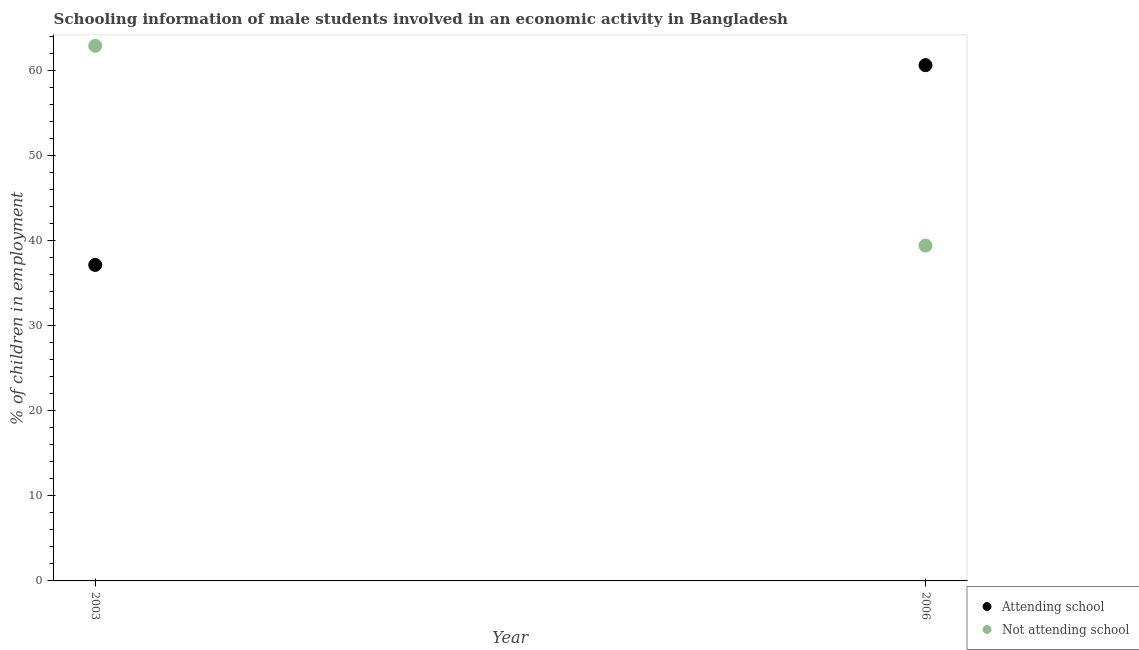What is the percentage of employed males who are not attending school in 2003?
Provide a succinct answer. 62.87. Across all years, what is the maximum percentage of employed males who are attending school?
Make the answer very short. 60.6. Across all years, what is the minimum percentage of employed males who are attending school?
Provide a succinct answer. 37.13. In which year was the percentage of employed males who are attending school maximum?
Your answer should be very brief. 2006. What is the total percentage of employed males who are attending school in the graph?
Offer a terse response. 97.73. What is the difference between the percentage of employed males who are not attending school in 2003 and that in 2006?
Your response must be concise. 23.47. What is the difference between the percentage of employed males who are attending school in 2003 and the percentage of employed males who are not attending school in 2006?
Your response must be concise. -2.27. What is the average percentage of employed males who are not attending school per year?
Your answer should be compact. 51.14. In the year 2006, what is the difference between the percentage of employed males who are attending school and percentage of employed males who are not attending school?
Provide a short and direct response. 21.2. What is the ratio of the percentage of employed males who are attending school in 2003 to that in 2006?
Make the answer very short. 0.61. Is the percentage of employed males who are attending school in 2003 less than that in 2006?
Your answer should be compact. Yes. In how many years, is the percentage of employed males who are attending school greater than the average percentage of employed males who are attending school taken over all years?
Your answer should be very brief. 1. Is the percentage of employed males who are attending school strictly less than the percentage of employed males who are not attending school over the years?
Offer a terse response. No. How many years are there in the graph?
Ensure brevity in your answer.  2. What is the difference between two consecutive major ticks on the Y-axis?
Your answer should be very brief. 10. How are the legend labels stacked?
Ensure brevity in your answer.  Vertical. What is the title of the graph?
Provide a succinct answer. Schooling information of male students involved in an economic activity in Bangladesh. Does "current US$" appear as one of the legend labels in the graph?
Make the answer very short. No. What is the label or title of the Y-axis?
Your answer should be compact. % of children in employment. What is the % of children in employment of Attending school in 2003?
Provide a short and direct response. 37.13. What is the % of children in employment in Not attending school in 2003?
Offer a terse response. 62.87. What is the % of children in employment in Attending school in 2006?
Give a very brief answer. 60.6. What is the % of children in employment in Not attending school in 2006?
Provide a succinct answer. 39.4. Across all years, what is the maximum % of children in employment of Attending school?
Offer a terse response. 60.6. Across all years, what is the maximum % of children in employment in Not attending school?
Your answer should be compact. 62.87. Across all years, what is the minimum % of children in employment in Attending school?
Provide a short and direct response. 37.13. Across all years, what is the minimum % of children in employment of Not attending school?
Offer a terse response. 39.4. What is the total % of children in employment in Attending school in the graph?
Provide a succinct answer. 97.73. What is the total % of children in employment in Not attending school in the graph?
Your answer should be compact. 102.27. What is the difference between the % of children in employment of Attending school in 2003 and that in 2006?
Provide a short and direct response. -23.47. What is the difference between the % of children in employment of Not attending school in 2003 and that in 2006?
Offer a terse response. 23.47. What is the difference between the % of children in employment in Attending school in 2003 and the % of children in employment in Not attending school in 2006?
Ensure brevity in your answer.  -2.27. What is the average % of children in employment of Attending school per year?
Your response must be concise. 48.86. What is the average % of children in employment of Not attending school per year?
Make the answer very short. 51.14. In the year 2003, what is the difference between the % of children in employment in Attending school and % of children in employment in Not attending school?
Your response must be concise. -25.74. In the year 2006, what is the difference between the % of children in employment in Attending school and % of children in employment in Not attending school?
Make the answer very short. 21.2. What is the ratio of the % of children in employment in Attending school in 2003 to that in 2006?
Provide a succinct answer. 0.61. What is the ratio of the % of children in employment of Not attending school in 2003 to that in 2006?
Offer a terse response. 1.6. What is the difference between the highest and the second highest % of children in employment in Attending school?
Your response must be concise. 23.47. What is the difference between the highest and the second highest % of children in employment of Not attending school?
Provide a short and direct response. 23.47. What is the difference between the highest and the lowest % of children in employment in Attending school?
Make the answer very short. 23.47. What is the difference between the highest and the lowest % of children in employment in Not attending school?
Provide a short and direct response. 23.47. 